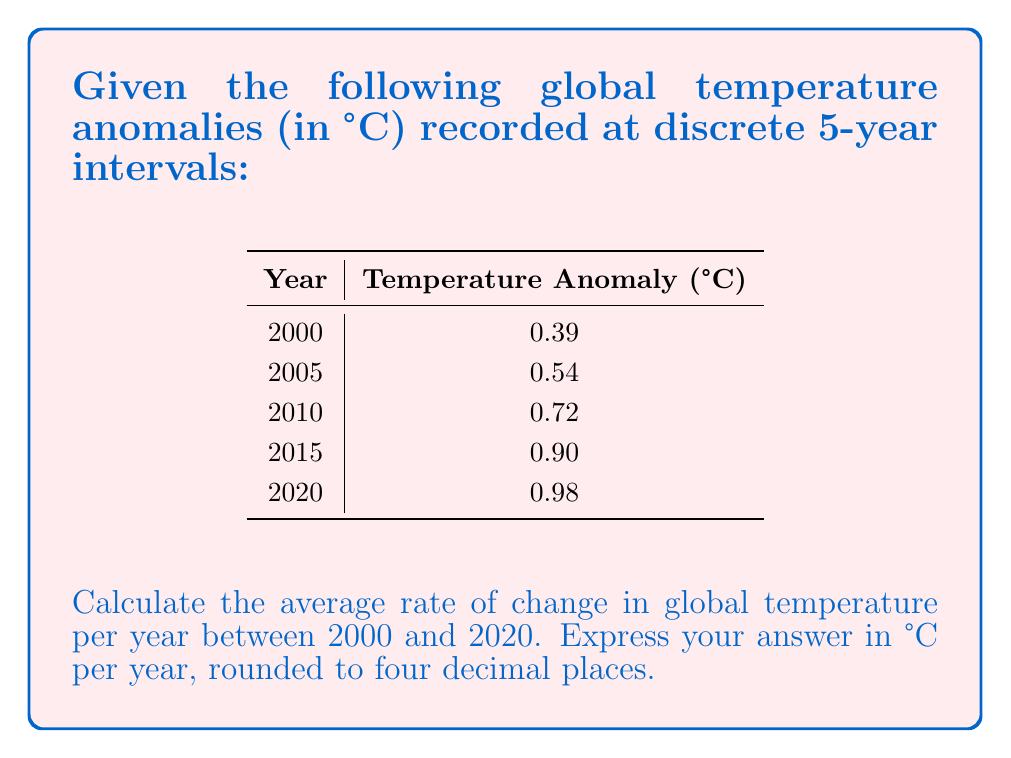Give your solution to this math problem. To solve this problem, we'll use the concept of average rate of change in discrete mathematics. The average rate of change is calculated by dividing the total change in the dependent variable (temperature) by the total change in the independent variable (time).

1) First, let's identify the total change in temperature:
   $\Delta T = T_{2020} - T_{2000} = 0.98°C - 0.39°C = 0.59°C$

2) Next, we need to determine the total time interval:
   $\Delta t = 2020 - 2000 = 20$ years

3) Now, we can calculate the average rate of change:
   $$\text{Rate of Change} = \frac{\Delta T}{\Delta t} = \frac{0.59°C}{20 \text{ years}}$$

4) Simplify the fraction:
   $$\frac{0.59}{20} = 0.0295°C/\text{year}$$

5) Rounding to four decimal places:
   $0.0295°C/\text{year} \approx 0.0295°C/\text{year}$

This result indicates that, on average, the global temperature increased by approximately 0.0295°C each year between 2000 and 2020.
Answer: $0.0295°C/\text{year}$ 